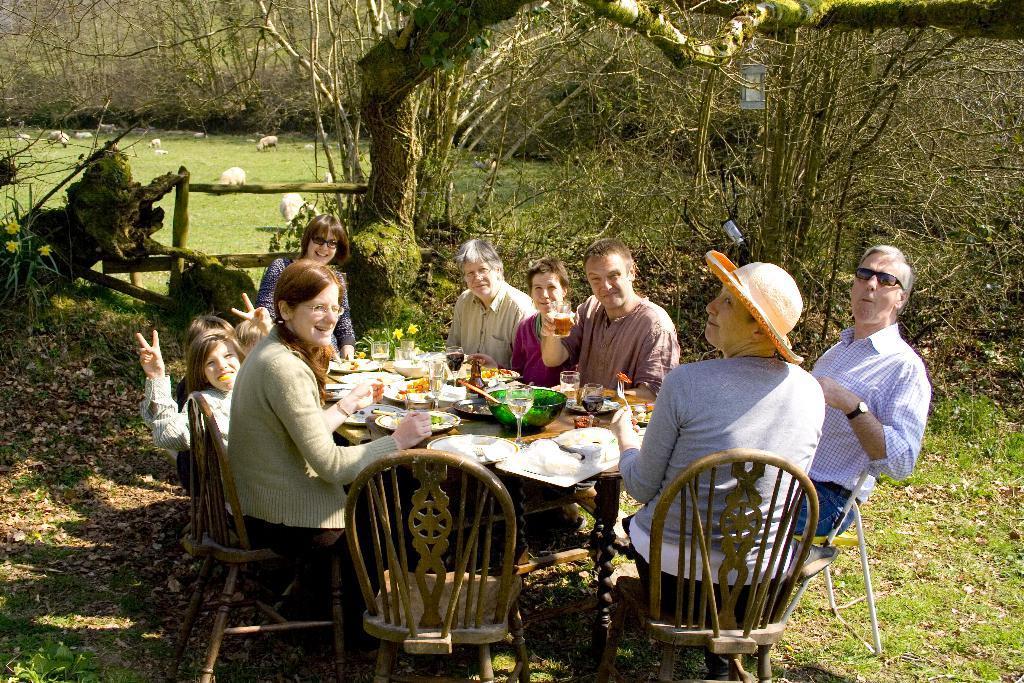Describe this image in one or two sentences. There is a group of people. They are sitting on a chairs. There is a table. There is a plate,bowl,glass,spoon ,tissue and food items on a table. We can see in background trees and animals. 